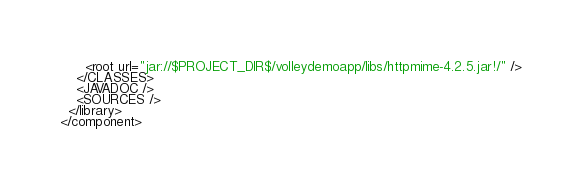<code> <loc_0><loc_0><loc_500><loc_500><_XML_>      <root url="jar://$PROJECT_DIR$/volleydemoapp/libs/httpmime-4.2.5.jar!/" />
    </CLASSES>
    <JAVADOC />
    <SOURCES />
  </library>
</component></code> 